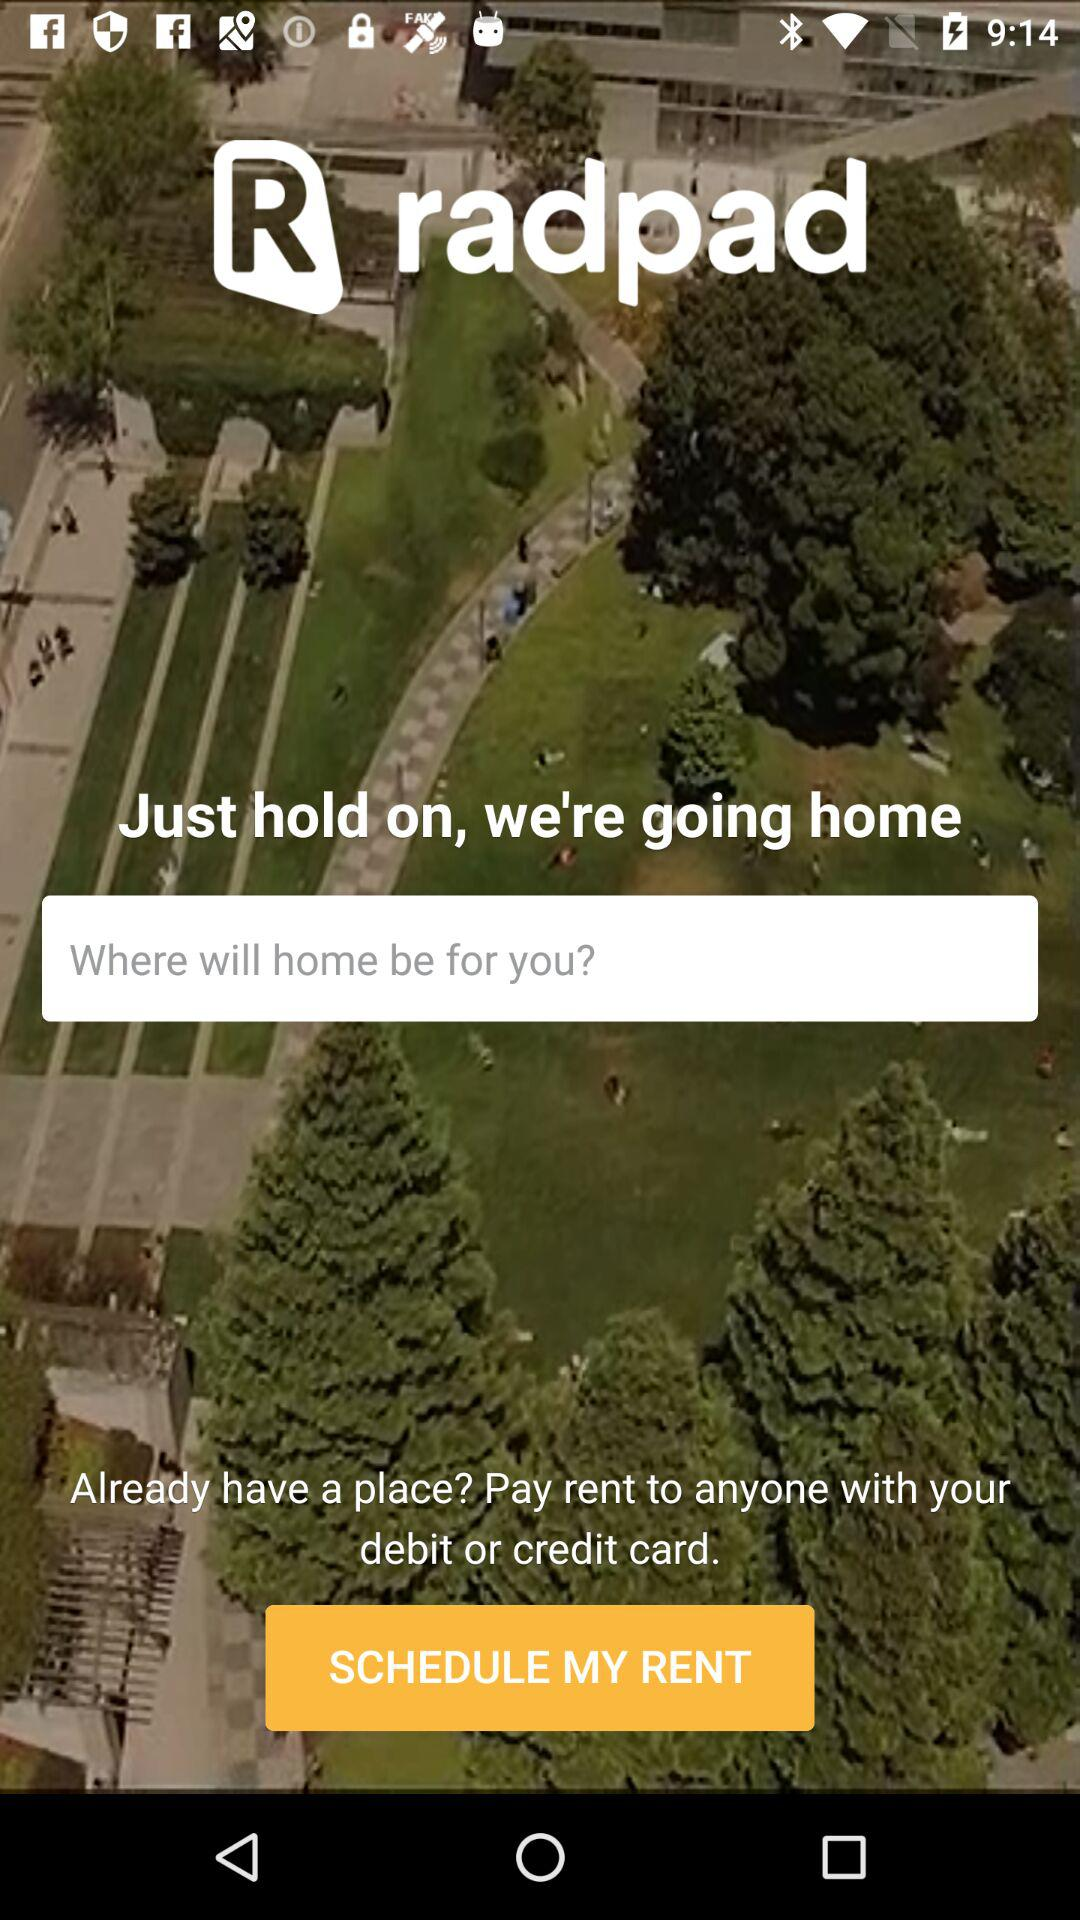What is the name of the application? The name of the application is "radpad". 